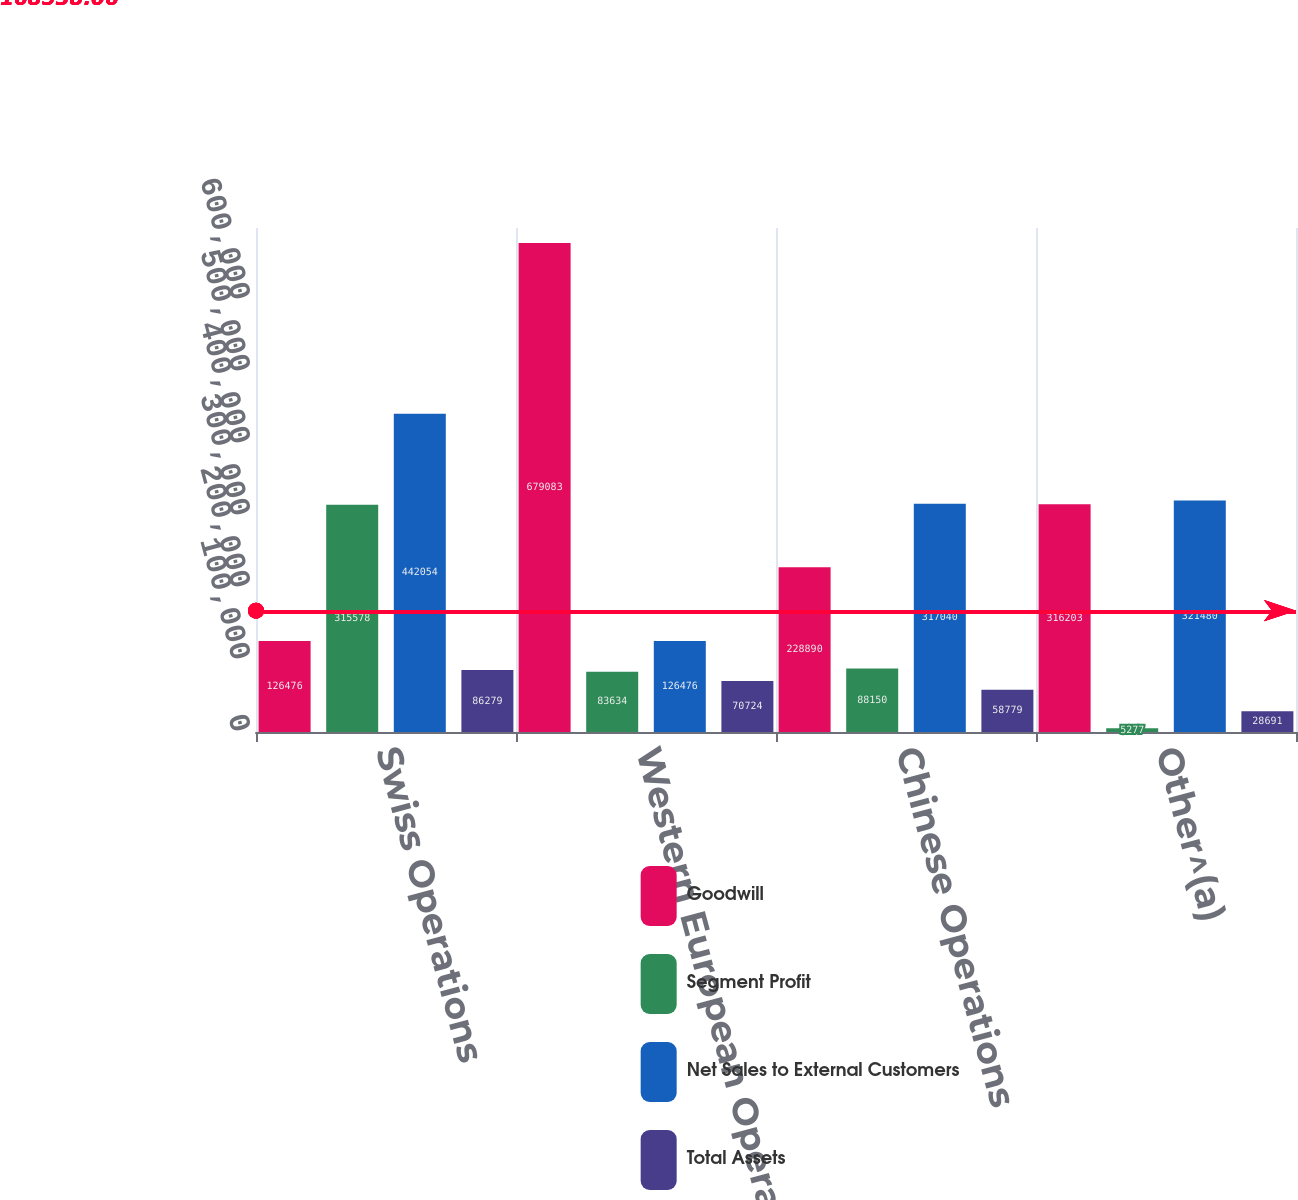Convert chart to OTSL. <chart><loc_0><loc_0><loc_500><loc_500><stacked_bar_chart><ecel><fcel>Swiss Operations<fcel>Western European Operations<fcel>Chinese Operations<fcel>Other^(a)<nl><fcel>Goodwill<fcel>126476<fcel>679083<fcel>228890<fcel>316203<nl><fcel>Segment Profit<fcel>315578<fcel>83634<fcel>88150<fcel>5277<nl><fcel>Net Sales to External Customers<fcel>442054<fcel>126476<fcel>317040<fcel>321480<nl><fcel>Total Assets<fcel>86279<fcel>70724<fcel>58779<fcel>28691<nl></chart> 